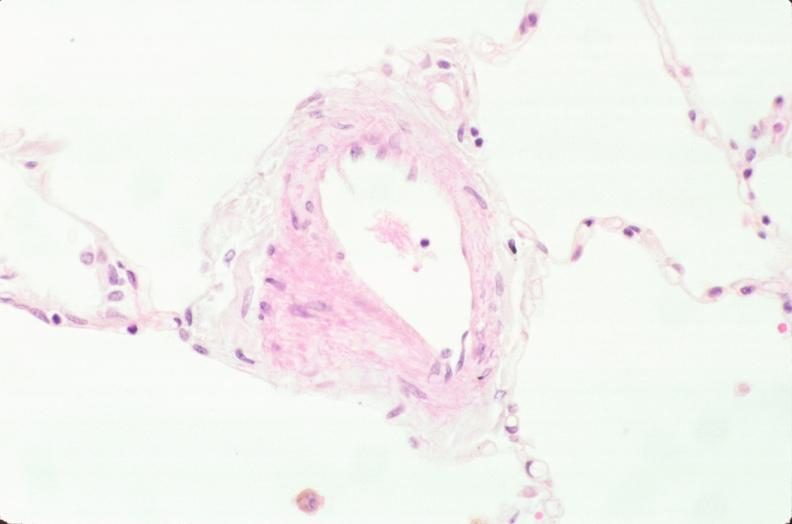s respiratory present?
Answer the question using a single word or phrase. Yes 